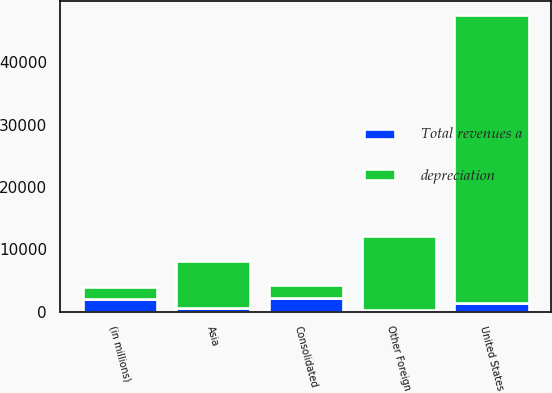<chart> <loc_0><loc_0><loc_500><loc_500><stacked_bar_chart><ecel><fcel>(in millions)<fcel>United States<fcel>Asia<fcel>Other Foreign<fcel>Consolidated<nl><fcel>depreciation<fcel>2012<fcel>46171<fcel>7635<fcel>11850<fcel>2012<nl><fcel>Total revenues a<fcel>2012<fcel>1391<fcel>516<fcel>306<fcel>2213<nl></chart> 